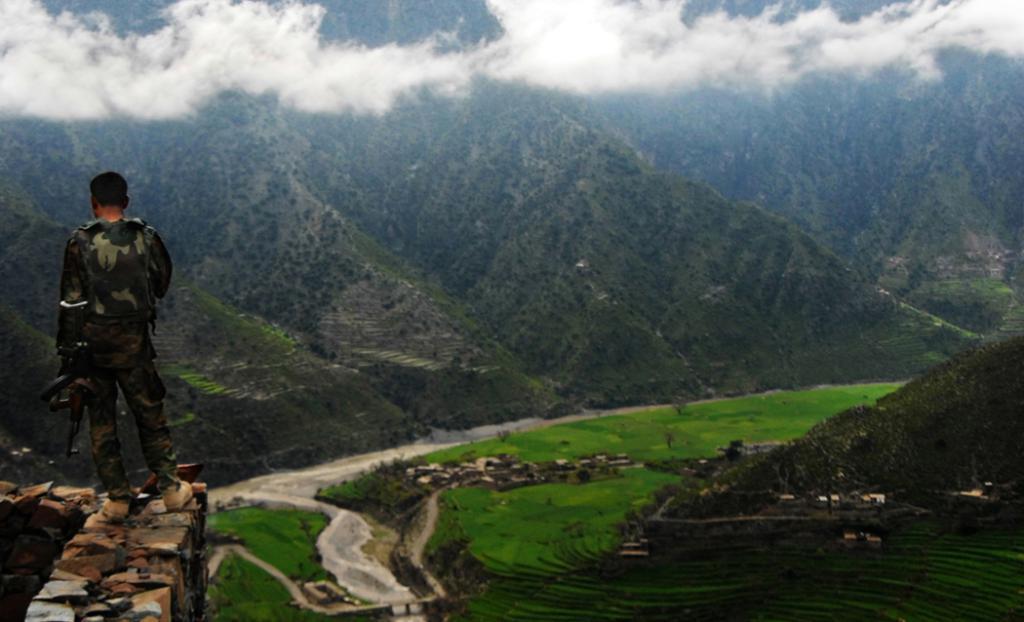Can you describe this image briefly? In the image there is a man with gun standing on wall on left side, in the front there is grassland in the bottom and there are many hills in the front with trees all over it and above its clouds. 